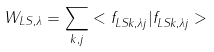<formula> <loc_0><loc_0><loc_500><loc_500>W _ { L S , \lambda } = \sum _ { k , j } < f _ { L S k , \lambda j } ^ { \, } | f _ { L S k , \lambda j } ^ { \, } ></formula> 